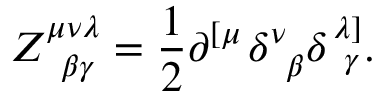<formula> <loc_0><loc_0><loc_500><loc_500>Z _ { \, \beta \gamma } ^ { \mu \nu \lambda } = \frac { 1 } { 2 } \partial ^ { \left [ \mu } \delta _ { \, \beta } ^ { \nu } \delta _ { \, \gamma } ^ { \lambda \right ] } .</formula> 